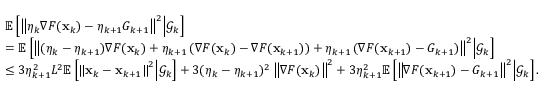Convert formula to latex. <formula><loc_0><loc_0><loc_500><loc_500>\begin{array} { r l } & { \mathbb { E } \left [ \left \| \eta _ { k } \nabla F ( x _ { k } ) - \eta _ { k + 1 } G _ { k + 1 } \right \| ^ { 2 } | d l e | \mathcal { G } _ { k } \right ] } \\ & { = \mathbb { E } \left [ \left \| ( \eta _ { k } - \eta _ { k + 1 } ) \nabla F ( x _ { k } ) + \eta _ { k + 1 } \left ( \nabla F ( x _ { k } ) - \nabla F ( x _ { k + 1 } ) \right ) + \eta _ { k + 1 } \left ( \nabla F ( x _ { k + 1 } ) - G _ { k + 1 } \right ) \right \| ^ { 2 } | d l e | \mathcal { G } _ { k } \right ] } \\ & { \leq 3 \eta _ { k + 1 } ^ { 2 } L ^ { 2 } \mathbb { E } \left [ \left \| x _ { k } - x _ { k + 1 } \right \| ^ { 2 } | d l e | \mathcal { G } _ { k } \right ] + 3 ( \eta _ { k } - \eta _ { k + 1 } ) ^ { 2 } \left \| \nabla F ( x _ { k } ) \right \| ^ { 2 } + 3 \eta _ { k + 1 } ^ { 2 } \mathbb { E } \left [ \left \| \nabla F ( x _ { k + 1 } ) - G _ { k + 1 } \right \| ^ { 2 } | d l e | \mathcal { G } _ { k } \right ] . } \end{array}</formula> 